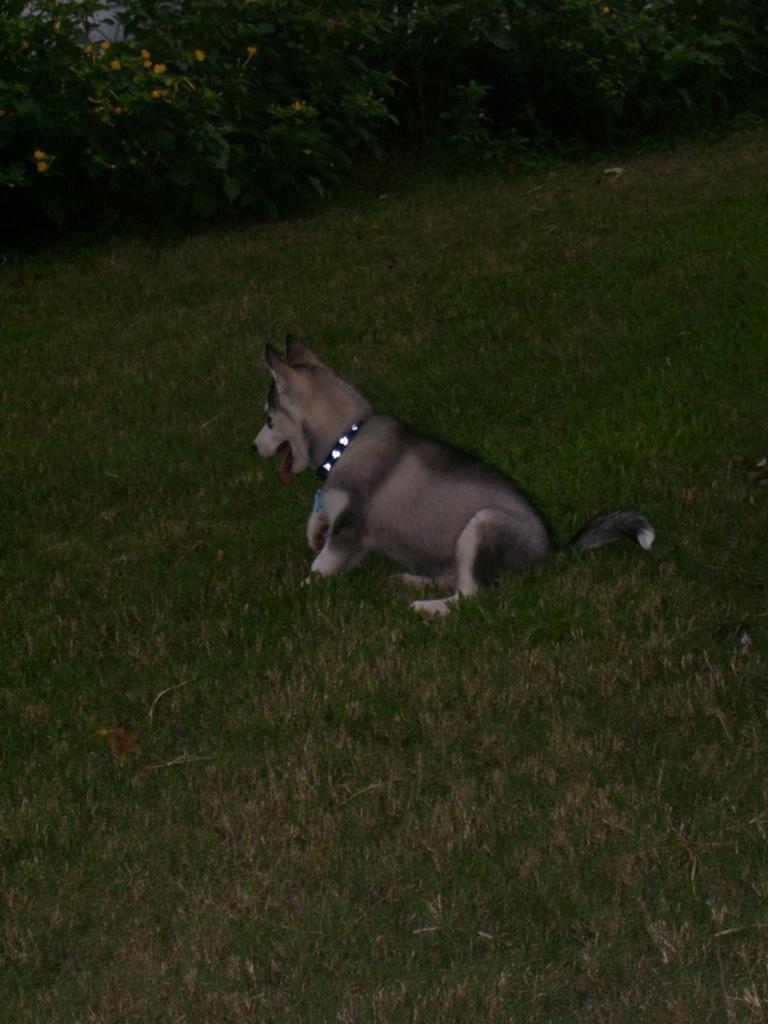Please provide a concise description of this image. In this image I can see some grass on the ground and a dog which is white and black in color on the ground. In the background I can see few trees and few flowers which are yellow in color. 